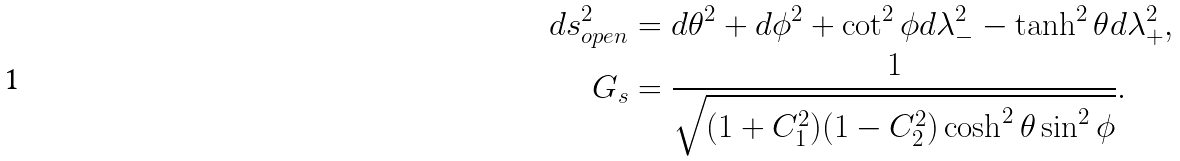Convert formula to latex. <formula><loc_0><loc_0><loc_500><loc_500>d s _ { o p e n } ^ { 2 } & = d \theta ^ { 2 } + d \phi ^ { 2 } + \cot ^ { 2 } \phi d \lambda _ { - } ^ { 2 } - \tanh ^ { 2 } \theta d \lambda _ { + } ^ { 2 } , \\ G _ { s } & = \frac { 1 } { \sqrt { ( 1 + C _ { 1 } ^ { 2 } ) ( 1 - C _ { 2 } ^ { 2 } ) \cosh ^ { 2 } \theta \sin ^ { 2 } \phi } } .</formula> 